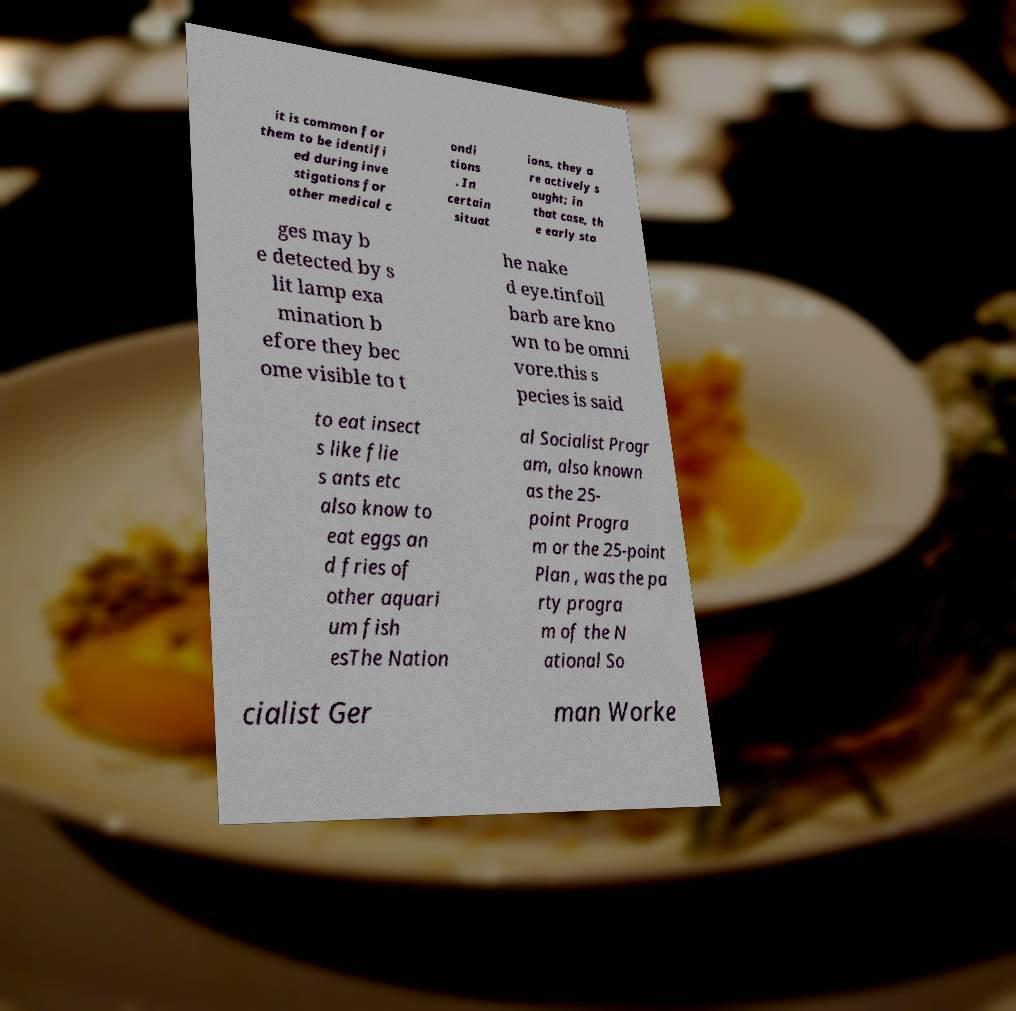Could you assist in decoding the text presented in this image and type it out clearly? it is common for them to be identifi ed during inve stigations for other medical c ondi tions . In certain situat ions, they a re actively s ought; in that case, th e early sta ges may b e detected by s lit lamp exa mination b efore they bec ome visible to t he nake d eye.tinfoil barb are kno wn to be omni vore.this s pecies is said to eat insect s like flie s ants etc also know to eat eggs an d fries of other aquari um fish esThe Nation al Socialist Progr am, also known as the 25- point Progra m or the 25-point Plan , was the pa rty progra m of the N ational So cialist Ger man Worke 